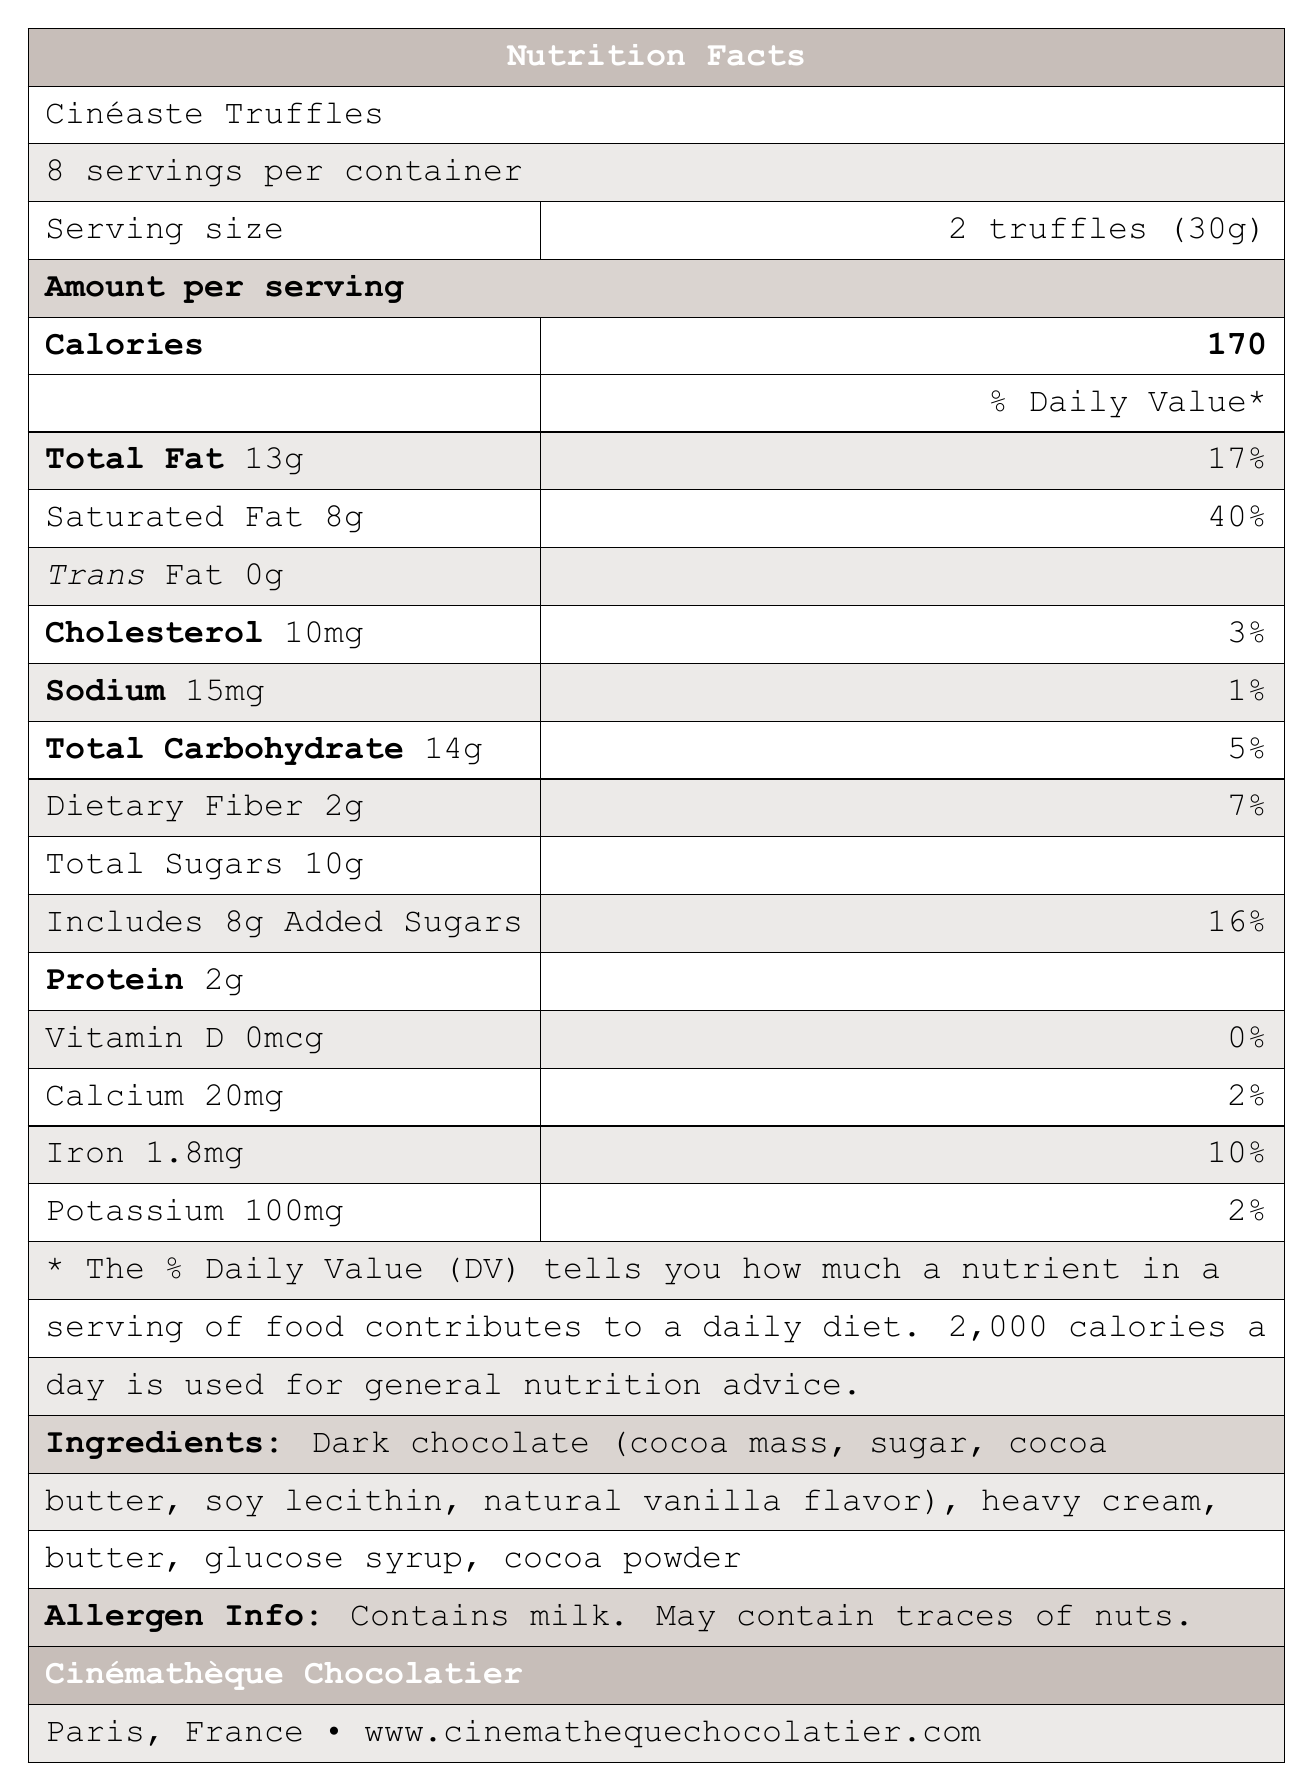what is the serving size for Cinéaste Truffles? The serving size is explicitly stated as "2 truffles (30g)" in the document.
Answer: 2 truffles (30g) how many calories are there per serving of Cinéaste Truffles? The document states that one serving contains 170 calories.
Answer: 170 what is the percentage of the daily value for saturated fat per serving? The percentage of the daily value for saturated fat per serving is listed as 40%.
Answer: 40% What ingredients are included in Cinéaste Truffles? The ingredients are listed under the section "Ingredients" in the document.
Answer: Dark chocolate (cocoa mass, sugar, cocoa butter, soy lecithin, natural vanilla flavor), heavy cream, butter, glucose syrup, cocoa powder How many grams of dietary fiber are in one serving of Cinéaste Truffles? The dietary fiber per serving is listed as 2g in the document.
Answer: 2g Which of the following allergens are present in Cinéaste Truffles? A. Wheat B. Milk C. Eggs D. Peanuts The document states that it contains milk under "Allergen Info".
Answer: B How much sodium is in one serving of Cinéaste Truffles? The amount of sodium per serving is listed as 15mg.
Answer: 15mg What is the daily value percentage for iron in one serving of Cinéaste Truffles? The document shows that one serving contains 10% of the daily value for iron.
Answer: 10% True or False: Cinéaste Truffles include added sugars. The document states that the product includes 8g of added sugars.
Answer: True How many servings are there per container? The document states that there are 8 servings per container.
Answer: 8 Which of the following truffle flavors includes yuzu as an ingredient? I. Kurosawa Matcha II. Fellini Espresso III. Bergman Lingonberry IV. Truffaut Cognac The Kurosawa Matcha flavor is described as having a hint of yuzu.
Answer: I What is the name of the company that makes Cinéaste Truffles? The document specifies the company name as Cinémathèque Chocolatier.
Answer: Cinémathèque Chocolatier What is the main idea of this document? The document contains sections on nutrition facts, ingredients, allergen information, truffle flavors, product description, storage instructions, and company information.
Answer: The document provides nutritional information, ingredients, allergen info, and company details for the artisanal chocolate truffles named Cinéaste Truffles, which are inspired by famous foreign film directors. What is the website for Cinémathèque Chocolatier? The company's website is listed at the bottom of the document.
Answer: www.cinemathequechocolatier.com How much protein is in one serving of Cinéaste Truffles? The document lists 2g of protein per serving.
Answer: 2g Is there enough information to determine how many grams of added sugars are in the entire container? Each serving has 8g of added sugars, and there are 8 servings per container; therefore, the entire container has 8 servings x 8g = 64g of added sugars.
Answer: Yes How many truffle flavors are detailed in the document? The document lists four truffle flavors: Kurosawa Matcha, Fellini Espresso, Bergman Lingonberry, and Truffaut Cognac.
Answer: 4 Can the document provide the exact amount of Vitamin D in one serving of Cinéaste Truffles? The document specifies that one serving contains 0mcg of Vitamin D.
Answer: Yes Will the information on allergen safety be enough for someone with a nut allergy to decide to consume the product? The document states that it may contain traces of nuts, so someone with a nut allergy may decide not to consume the product.
Answer: No 